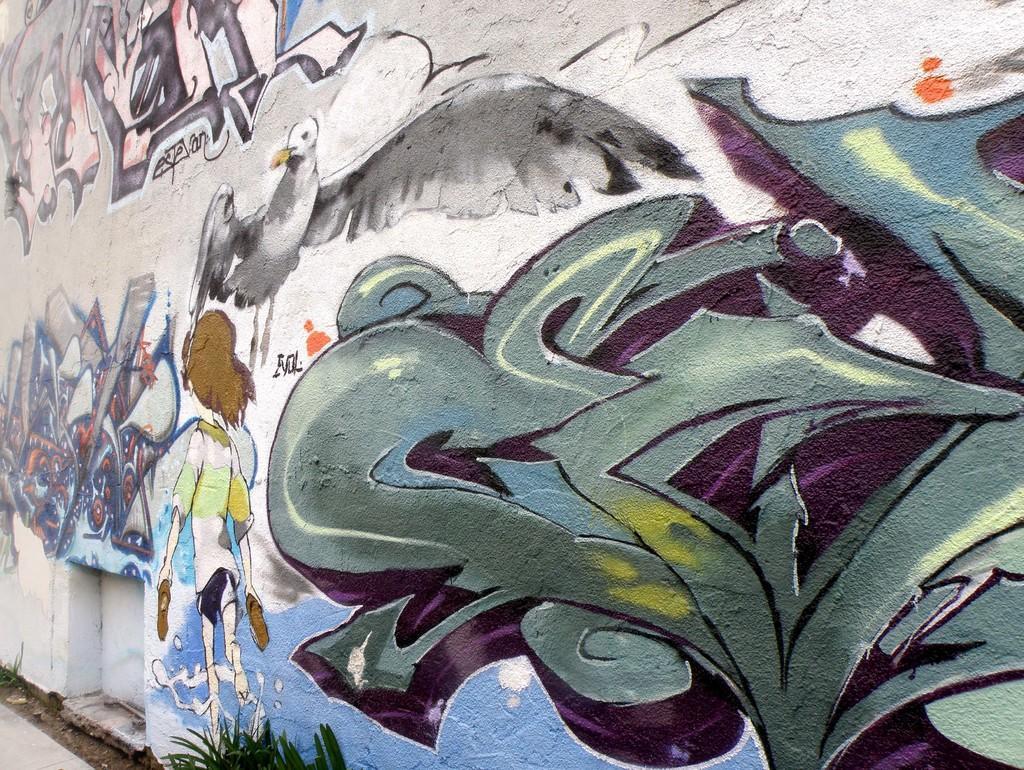Describe this image in one or two sentences. This image consists of a wall on which there are paintings. It looks like a graffiti. At the bottom, there is a ground and a plant. 